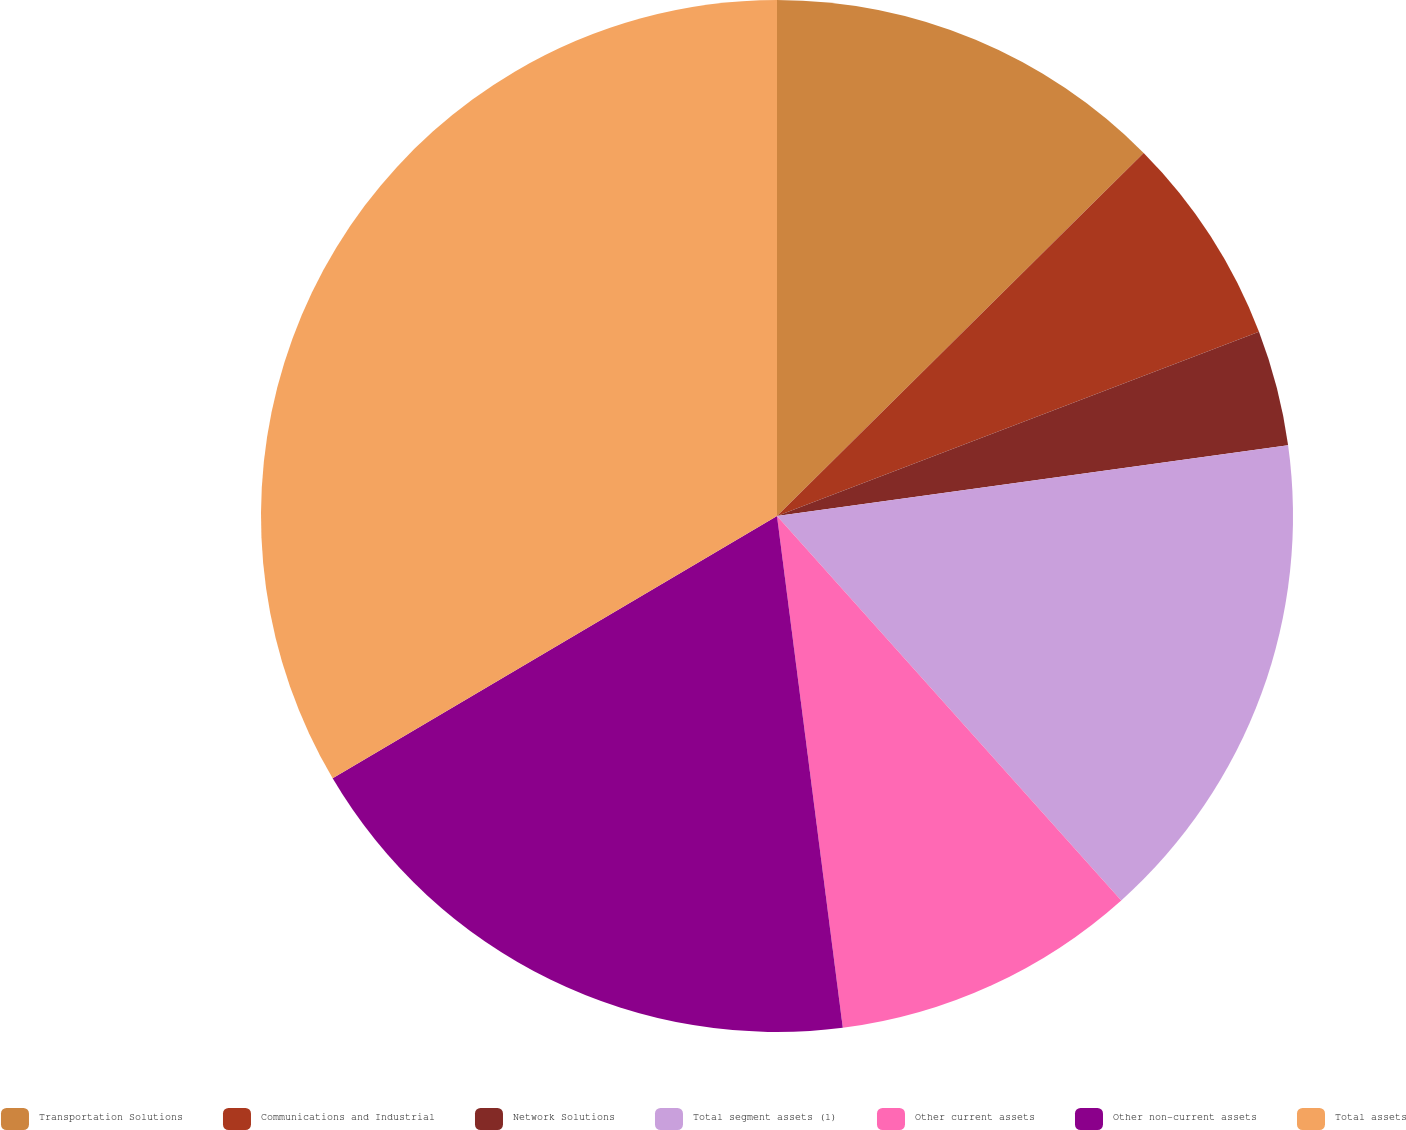Convert chart. <chart><loc_0><loc_0><loc_500><loc_500><pie_chart><fcel>Transportation Solutions<fcel>Communications and Industrial<fcel>Network Solutions<fcel>Total segment assets (1)<fcel>Other current assets<fcel>Other non-current assets<fcel>Total assets<nl><fcel>12.58%<fcel>6.61%<fcel>3.62%<fcel>15.57%<fcel>9.59%<fcel>18.55%<fcel>33.49%<nl></chart> 